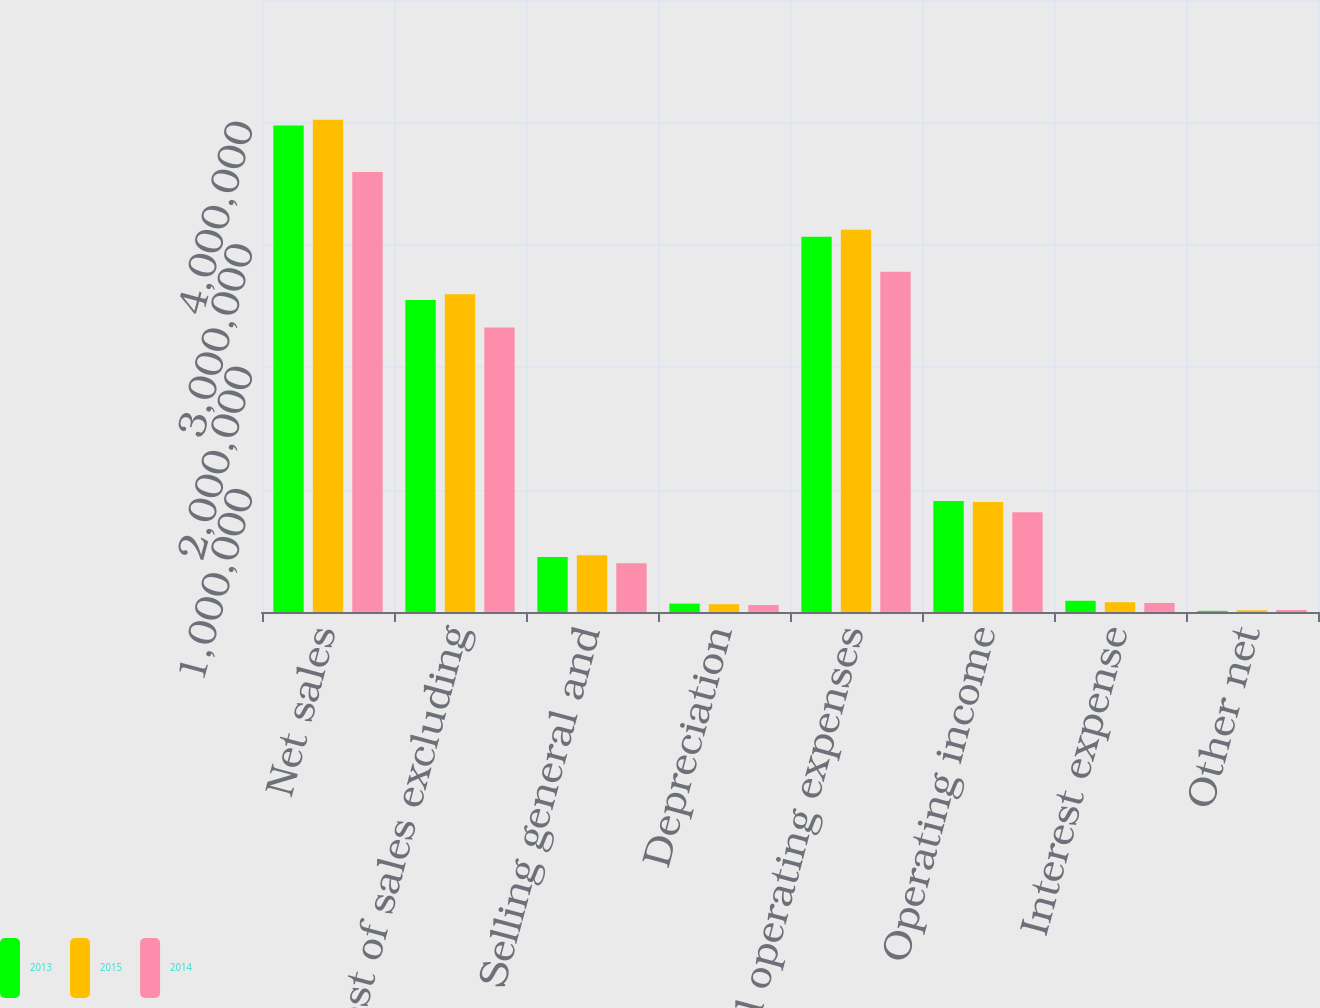<chart> <loc_0><loc_0><loc_500><loc_500><stacked_bar_chart><ecel><fcel>Net sales<fcel>Cost of sales excluding<fcel>Selling general and<fcel>Depreciation<fcel>Total operating expenses<fcel>Operating income<fcel>Interest expense<fcel>Other net<nl><fcel>2013<fcel>3.9743e+06<fcel>2.54928e+06<fcel>448592<fcel>68707<fcel>3.06658e+06<fcel>907716<fcel>91795<fcel>9541<nl><fcel>2015<fcel>4.02196e+06<fcel>2.59702e+06<fcel>462637<fcel>63724<fcel>3.12338e+06<fcel>898586<fcel>79928<fcel>13826<nl><fcel>2014<fcel>3.59414e+06<fcel>2.32364e+06<fcel>398177<fcel>57238<fcel>2.77906e+06<fcel>815079<fcel>73572<fcel>16712<nl></chart> 